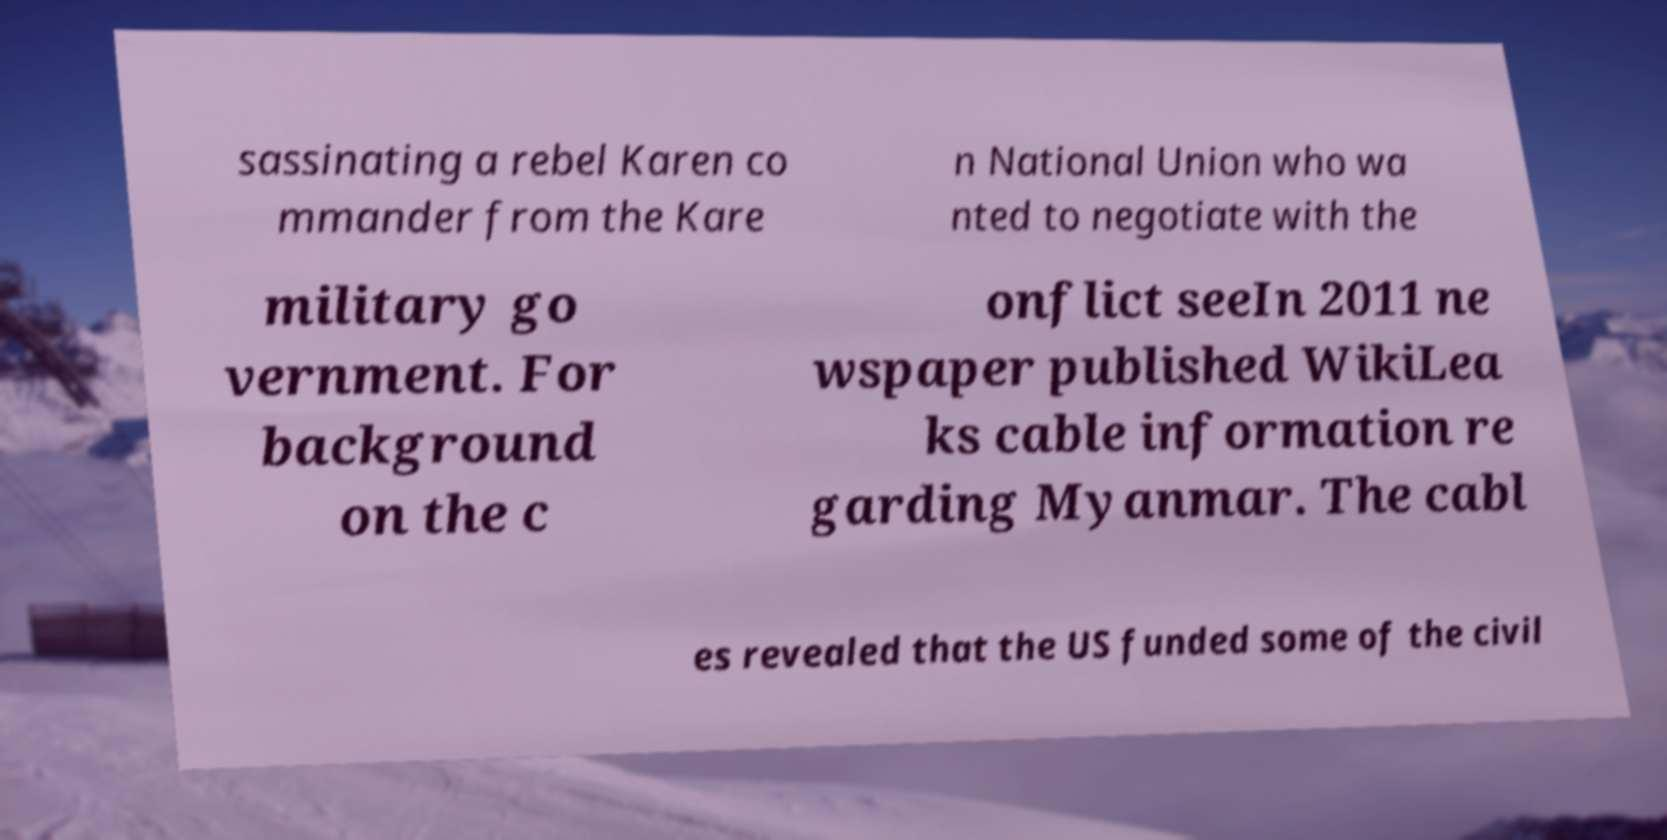What messages or text are displayed in this image? I need them in a readable, typed format. sassinating a rebel Karen co mmander from the Kare n National Union who wa nted to negotiate with the military go vernment. For background on the c onflict seeIn 2011 ne wspaper published WikiLea ks cable information re garding Myanmar. The cabl es revealed that the US funded some of the civil 